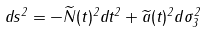Convert formula to latex. <formula><loc_0><loc_0><loc_500><loc_500>d s ^ { 2 } = - \widetilde { N } ( t ) ^ { 2 } d t ^ { 2 } + \widetilde { a } ( t ) ^ { 2 } d \sigma _ { 3 } ^ { 2 }</formula> 